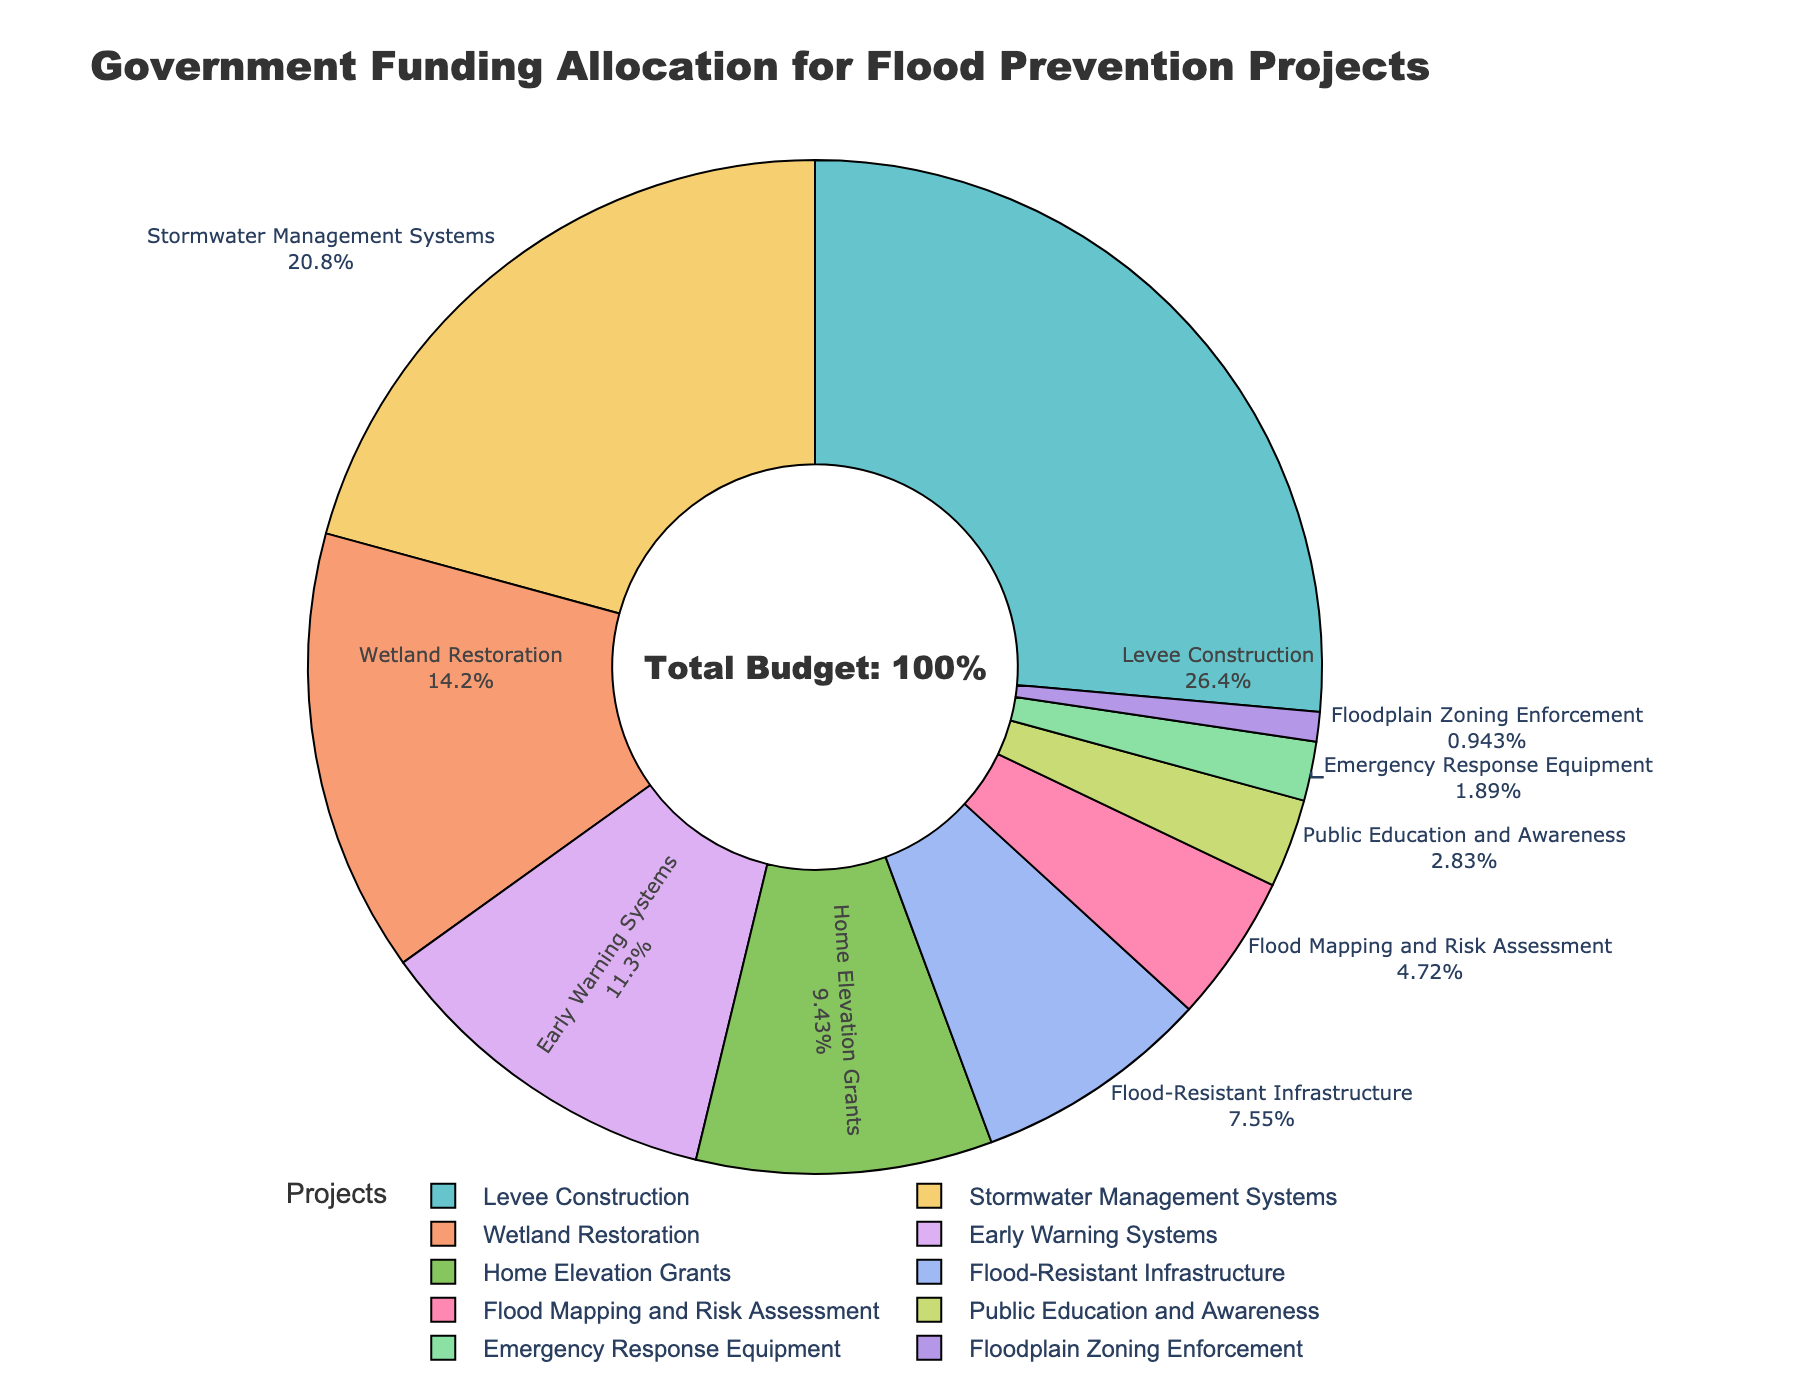What percentage of the funding is allocated to Early Warning Systems? Locate the segment labeled "Early Warning Systems" on the pie chart, which shows its percentage as 12%
Answer: 12% What is the combined funding percentage for Wetland Restoration and Home Elevation Grants? Find the individual percentages for Wetland Restoration (15%) and Home Elevation Grants (10%), then sum them: 15% + 10% = 25%
Answer: 25% Which flood prevention project receives the highest funding? Identify the segment with the largest area, which is labeled "Levee Construction" at 28%
Answer: Levee Construction Is the funding for Flood Mapping and Risk Assessment greater than the funding for Public Education and Awareness? Compare the percentages directly: Flood Mapping and Risk Assessment is 5%, and Public Education and Awareness is 3%; 5% is greater than 3%
Answer: Yes What is the total percentage allocated to projects other than Levee Construction? Subtract the percentage of Levee Construction (28%) from the total (100%): 100% - 28% = 72%
Answer: 72% Are there more projects with funding allocations above 10% or below 10%? Count projects with percentages above 10% (Levee Construction, Stormwater Management Systems, Wetland Restoration, Early Warning Systems, and Home Elevation Grants, total = 5) and below 10% (Flood-Resistant Infrastructure, Flood Mapping and Risk Assessment, Public Education and Awareness, Emergency Response Equipment, Floodplain Zoning Enforcement, total = 5). Both categories have equal numbers
Answer: Equal numbers Which two projects together have the smallest combined funding percentage? Identify the two segments with the smallest percentages: Public Education and Awareness (3%) and Floodplain Zoning Enforcement (1%), then sum them: 3% + 1% = 4%
Answer: Public Education and Awareness and Floodplain Zoning Enforcement How does the funding for Stormwater Management Systems compare to Flood-Resistant Infrastructure? Compare the percentages: Stormwater Management Systems is 22%, and Flood-Resistant Infrastructure is 8%; 22% is greater than 8%
Answer: Stormwater Management Systems has more funding 